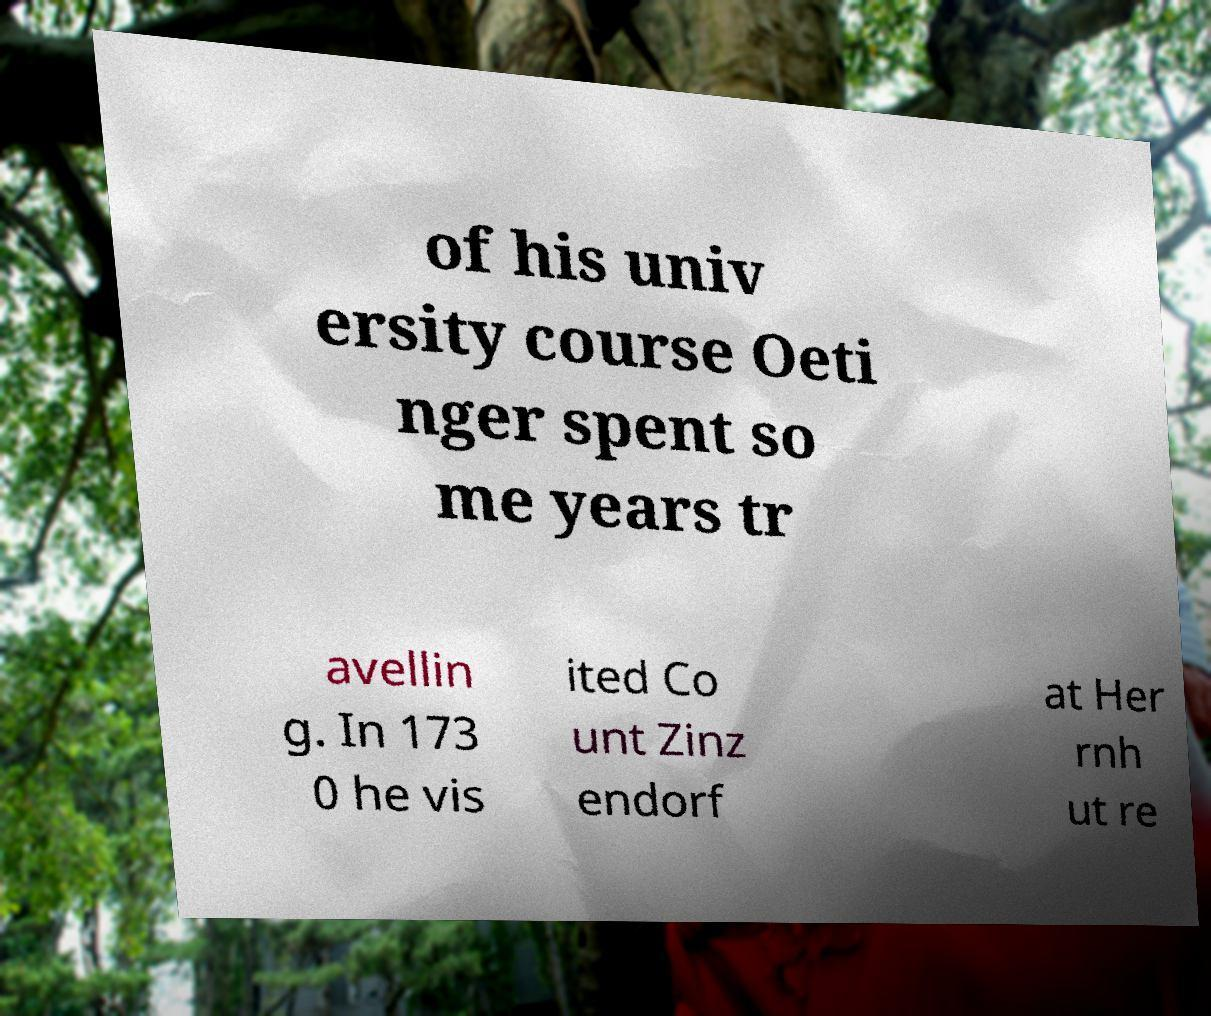Please read and relay the text visible in this image. What does it say? of his univ ersity course Oeti nger spent so me years tr avellin g. In 173 0 he vis ited Co unt Zinz endorf at Her rnh ut re 